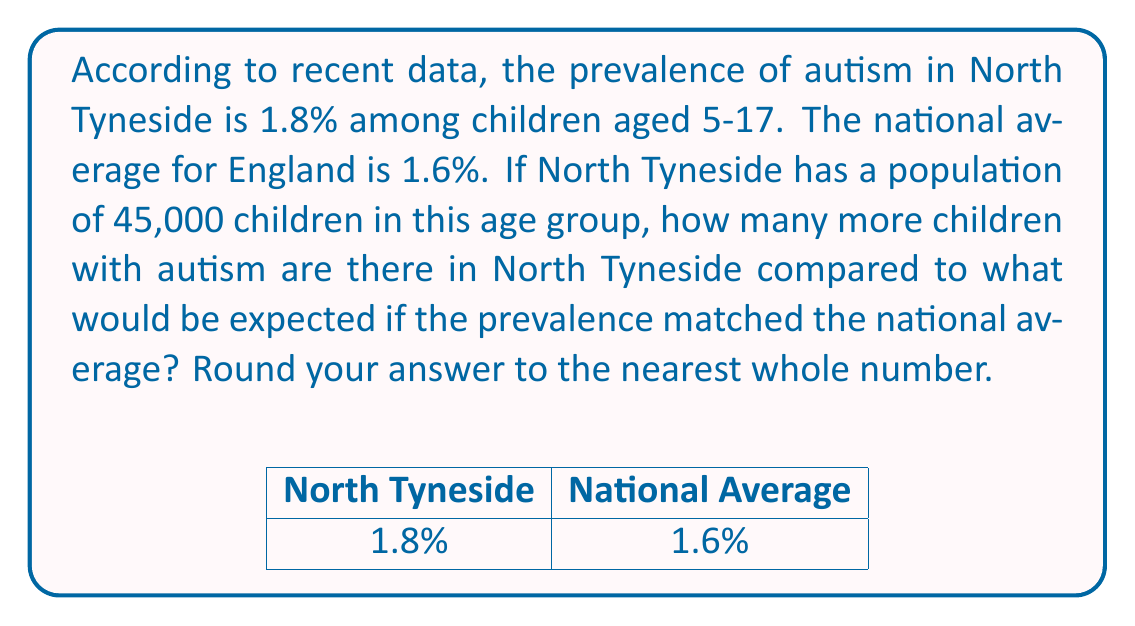Help me with this question. Let's approach this step-by-step:

1) First, calculate the number of children with autism in North Tyneside:
   $$ 45,000 \times 1.8\% = 45,000 \times 0.018 = 810 $$

2) Now, calculate how many children would have autism if North Tyneside matched the national average:
   $$ 45,000 \times 1.6\% = 45,000 \times 0.016 = 720 $$

3) To find the difference, subtract the national average expectation from the actual number:
   $$ 810 - 720 = 90 $$

4) The question asks to round to the nearest whole number, but 90 is already a whole number, so no rounding is necessary.

Therefore, there are 90 more children with autism in North Tyneside compared to what would be expected if the prevalence matched the national average.
Answer: 90 children 